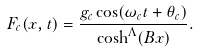<formula> <loc_0><loc_0><loc_500><loc_500>F _ { c } ( x , t ) = \frac { g _ { c } \cos ( \omega _ { c } t + \theta _ { c } ) } { \cosh ^ { \Lambda } ( B x ) } .</formula> 